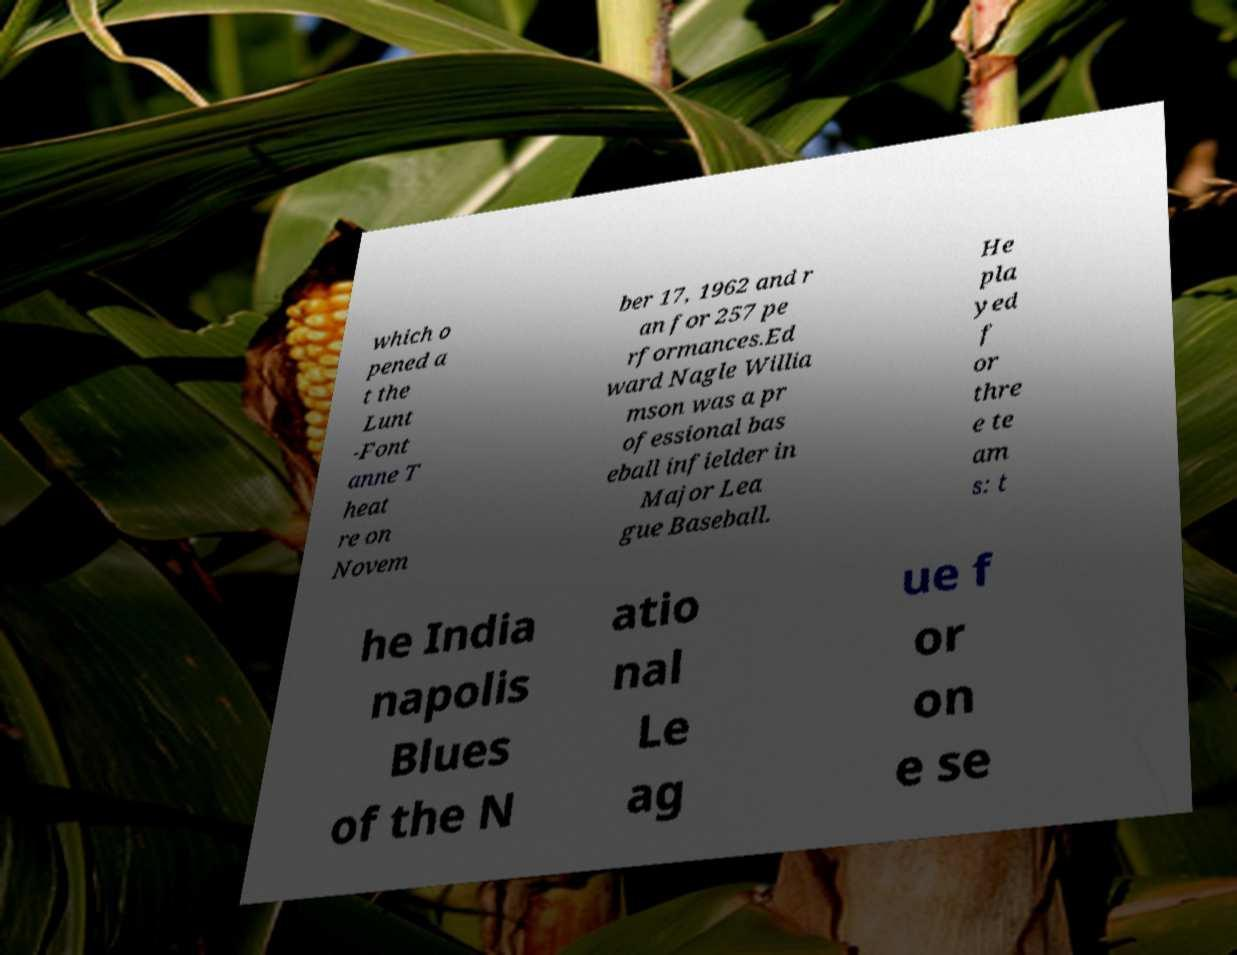What messages or text are displayed in this image? I need them in a readable, typed format. which o pened a t the Lunt -Font anne T heat re on Novem ber 17, 1962 and r an for 257 pe rformances.Ed ward Nagle Willia mson was a pr ofessional bas eball infielder in Major Lea gue Baseball. He pla yed f or thre e te am s: t he India napolis Blues of the N atio nal Le ag ue f or on e se 